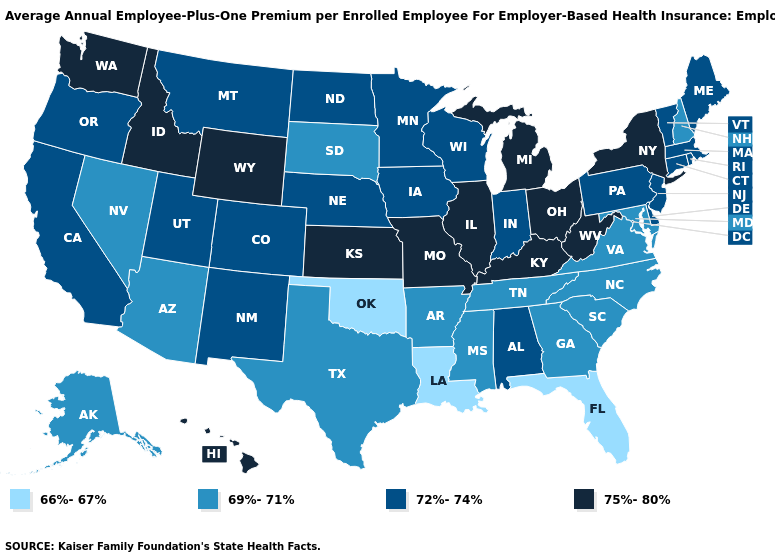Does New Jersey have the highest value in the USA?
Quick response, please. No. How many symbols are there in the legend?
Short answer required. 4. What is the highest value in the MidWest ?
Quick response, please. 75%-80%. Name the states that have a value in the range 75%-80%?
Quick response, please. Hawaii, Idaho, Illinois, Kansas, Kentucky, Michigan, Missouri, New York, Ohio, Washington, West Virginia, Wyoming. Which states have the lowest value in the USA?
Short answer required. Florida, Louisiana, Oklahoma. How many symbols are there in the legend?
Short answer required. 4. What is the highest value in the South ?
Answer briefly. 75%-80%. Name the states that have a value in the range 69%-71%?
Be succinct. Alaska, Arizona, Arkansas, Georgia, Maryland, Mississippi, Nevada, New Hampshire, North Carolina, South Carolina, South Dakota, Tennessee, Texas, Virginia. What is the value of North Dakota?
Concise answer only. 72%-74%. Does Connecticut have the lowest value in the Northeast?
Answer briefly. No. Among the states that border Oregon , which have the highest value?
Concise answer only. Idaho, Washington. What is the highest value in the Northeast ?
Quick response, please. 75%-80%. Among the states that border Idaho , which have the highest value?
Quick response, please. Washington, Wyoming. What is the value of Wisconsin?
Keep it brief. 72%-74%. Does Indiana have the highest value in the MidWest?
Quick response, please. No. 